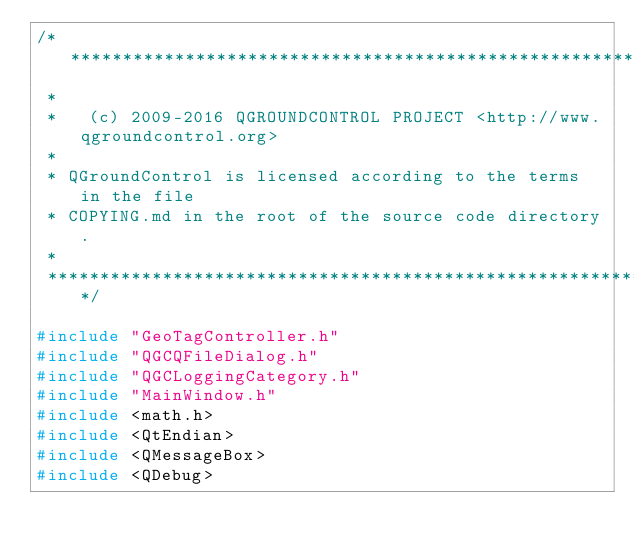<code> <loc_0><loc_0><loc_500><loc_500><_C++_>/****************************************************************************
 *
 *   (c) 2009-2016 QGROUNDCONTROL PROJECT <http://www.qgroundcontrol.org>
 *
 * QGroundControl is licensed according to the terms in the file
 * COPYING.md in the root of the source code directory.
 *
 ****************************************************************************/

#include "GeoTagController.h"
#include "QGCQFileDialog.h"
#include "QGCLoggingCategory.h"
#include "MainWindow.h"
#include <math.h>
#include <QtEndian>
#include <QMessageBox>
#include <QDebug></code> 